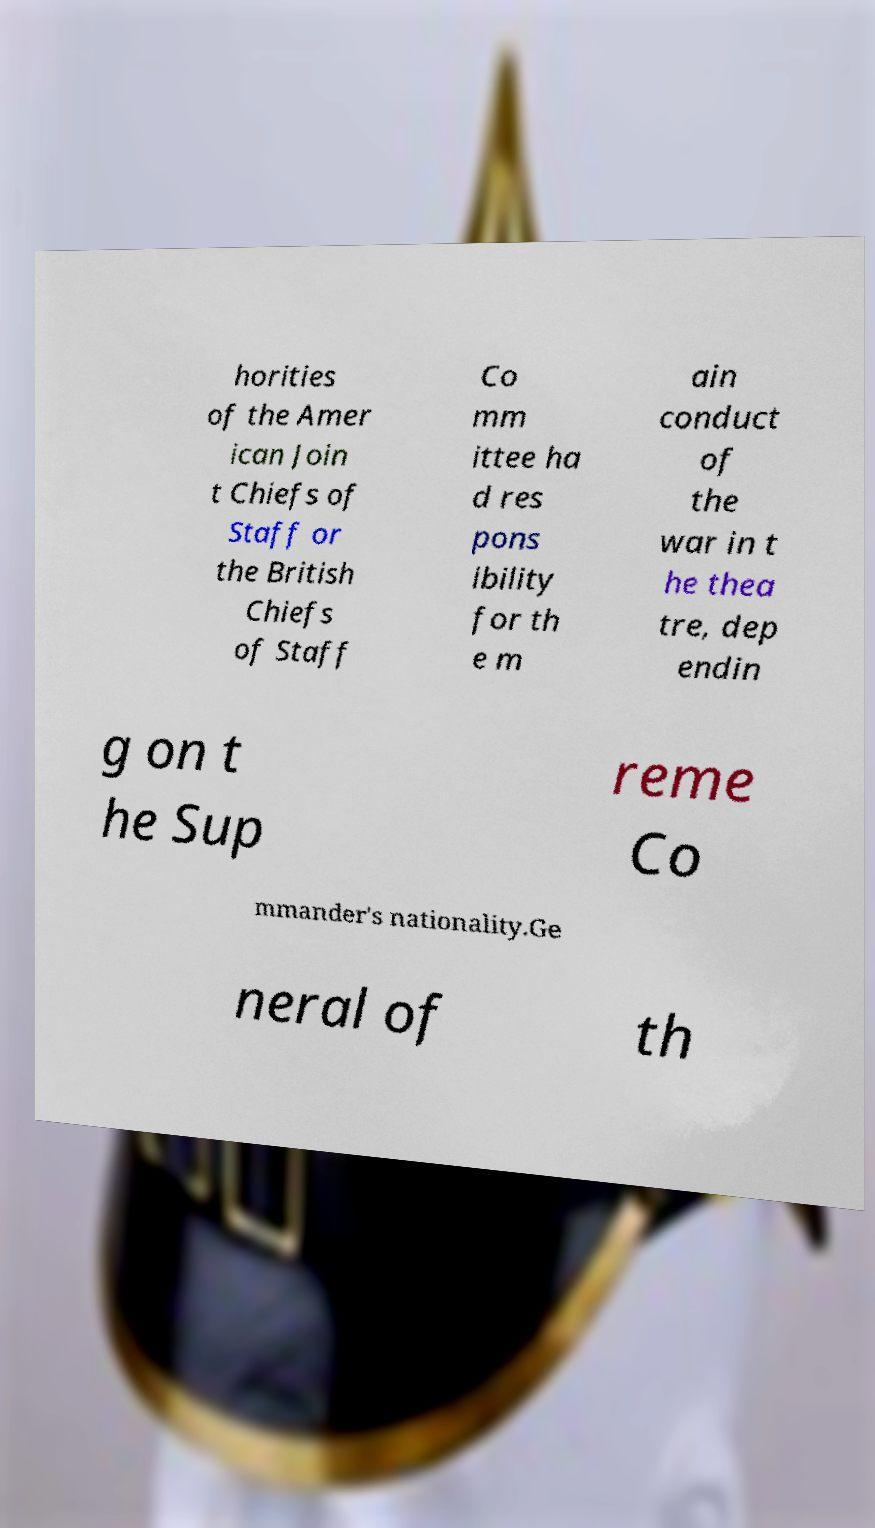There's text embedded in this image that I need extracted. Can you transcribe it verbatim? horities of the Amer ican Join t Chiefs of Staff or the British Chiefs of Staff Co mm ittee ha d res pons ibility for th e m ain conduct of the war in t he thea tre, dep endin g on t he Sup reme Co mmander's nationality.Ge neral of th 